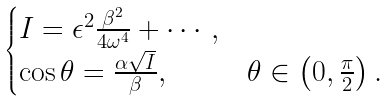<formula> <loc_0><loc_0><loc_500><loc_500>\begin{cases} I = \epsilon ^ { 2 } \frac { \beta ^ { 2 } } { 4 \omega ^ { 4 } } + \cdots , \\ \cos \theta = \frac { \alpha \sqrt { I } } { \beta } , & \theta \in \left ( 0 , \frac { \pi } { 2 } \right ) . \end{cases}</formula> 